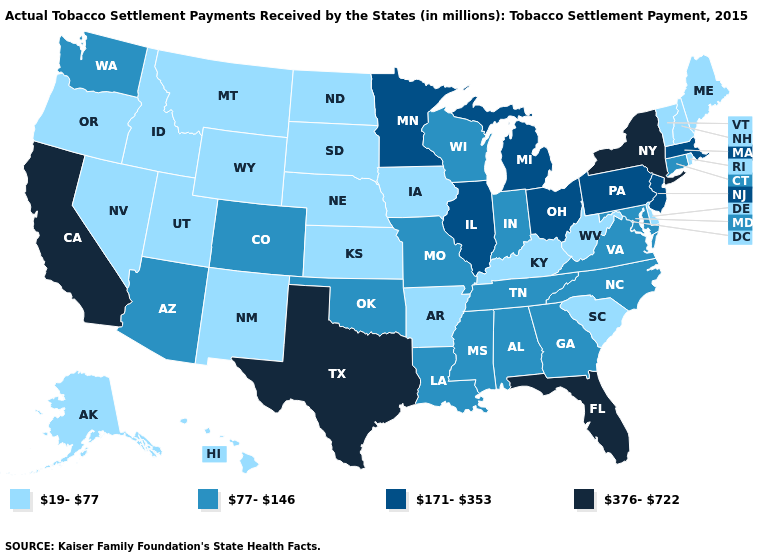Name the states that have a value in the range 77-146?
Answer briefly. Alabama, Arizona, Colorado, Connecticut, Georgia, Indiana, Louisiana, Maryland, Mississippi, Missouri, North Carolina, Oklahoma, Tennessee, Virginia, Washington, Wisconsin. What is the value of Minnesota?
Write a very short answer. 171-353. How many symbols are there in the legend?
Answer briefly. 4. What is the highest value in the MidWest ?
Answer briefly. 171-353. Name the states that have a value in the range 19-77?
Concise answer only. Alaska, Arkansas, Delaware, Hawaii, Idaho, Iowa, Kansas, Kentucky, Maine, Montana, Nebraska, Nevada, New Hampshire, New Mexico, North Dakota, Oregon, Rhode Island, South Carolina, South Dakota, Utah, Vermont, West Virginia, Wyoming. Name the states that have a value in the range 77-146?
Be succinct. Alabama, Arizona, Colorado, Connecticut, Georgia, Indiana, Louisiana, Maryland, Mississippi, Missouri, North Carolina, Oklahoma, Tennessee, Virginia, Washington, Wisconsin. What is the highest value in states that border California?
Quick response, please. 77-146. Which states have the lowest value in the USA?
Answer briefly. Alaska, Arkansas, Delaware, Hawaii, Idaho, Iowa, Kansas, Kentucky, Maine, Montana, Nebraska, Nevada, New Hampshire, New Mexico, North Dakota, Oregon, Rhode Island, South Carolina, South Dakota, Utah, Vermont, West Virginia, Wyoming. Name the states that have a value in the range 19-77?
Short answer required. Alaska, Arkansas, Delaware, Hawaii, Idaho, Iowa, Kansas, Kentucky, Maine, Montana, Nebraska, Nevada, New Hampshire, New Mexico, North Dakota, Oregon, Rhode Island, South Carolina, South Dakota, Utah, Vermont, West Virginia, Wyoming. Does Wyoming have the highest value in the West?
Short answer required. No. Name the states that have a value in the range 171-353?
Short answer required. Illinois, Massachusetts, Michigan, Minnesota, New Jersey, Ohio, Pennsylvania. Name the states that have a value in the range 376-722?
Quick response, please. California, Florida, New York, Texas. Name the states that have a value in the range 77-146?
Write a very short answer. Alabama, Arizona, Colorado, Connecticut, Georgia, Indiana, Louisiana, Maryland, Mississippi, Missouri, North Carolina, Oklahoma, Tennessee, Virginia, Washington, Wisconsin. What is the lowest value in the USA?
Short answer required. 19-77. 